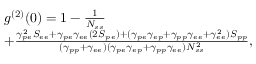Convert formula to latex. <formula><loc_0><loc_0><loc_500><loc_500>\begin{array} { r l } & { g ^ { ( 2 ) } ( 0 ) = 1 - \frac { 1 } { N _ { s s } } } \\ & { + \frac { \gamma _ { p e } ^ { 2 } S _ { e e } + \gamma _ { p e } \gamma _ { e e } ( 2 S _ { p \, e } ) + ( \gamma _ { p e } \gamma _ { e p } + \gamma _ { p p } \gamma _ { e e } + \gamma _ { e e } ^ { 2 } ) S _ { p p } } { ( \gamma _ { p p } + \gamma _ { e e } ) ( \gamma _ { p e } \gamma _ { e p } + \gamma _ { p p } \gamma _ { e e } ) N _ { s s } ^ { 2 } } , } \end{array}</formula> 